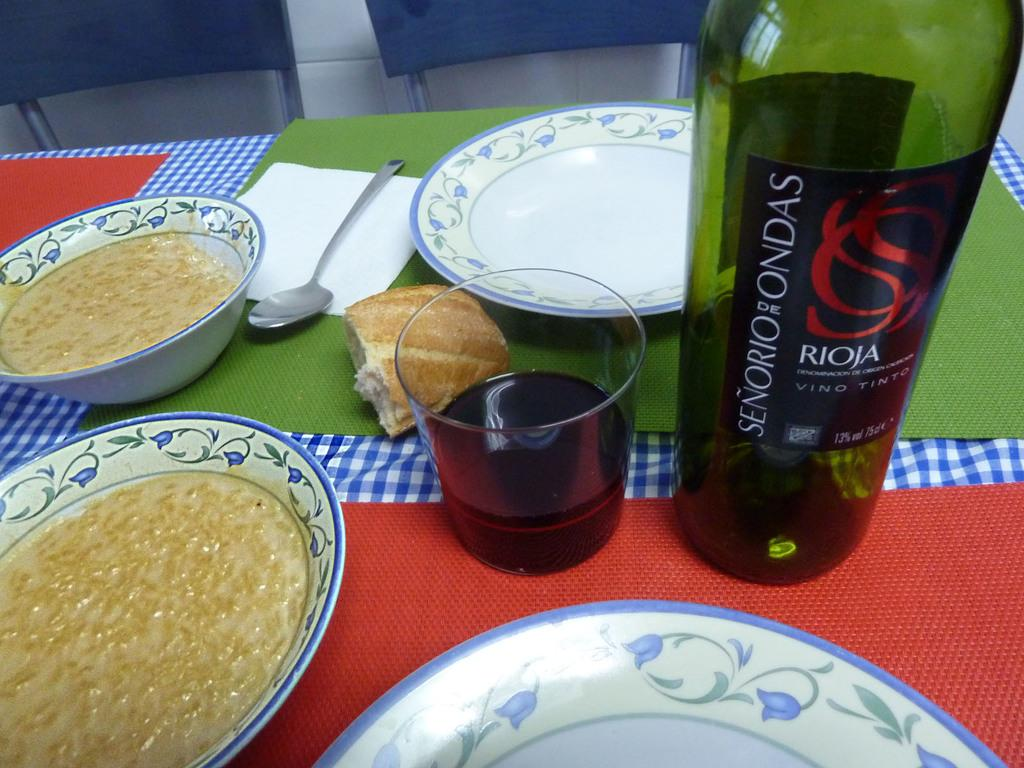What objects are present in the image that are typically used for eating? There are plates, a bowl, a spoon, and a glass in the image that are typically used for eating. What is in the plates in the image? There is food in the plates in the image. What type of container is present in the image for holding a beverage? There is a water bottle in the image for holding a beverage. How many chairs are visible in the image? There are two chairs in the image. What type of prose can be heard being recited on the stage in the image? There is no stage or prose present in the image; it features plates, food, a bowl, a spoon, a water bottle, a glass, and two chairs. What type of drum is visible on the table in the image? There is no drum present in the image; it features plates, food, a bowl, a spoon, a water bottle, a glass, and two chairs. 